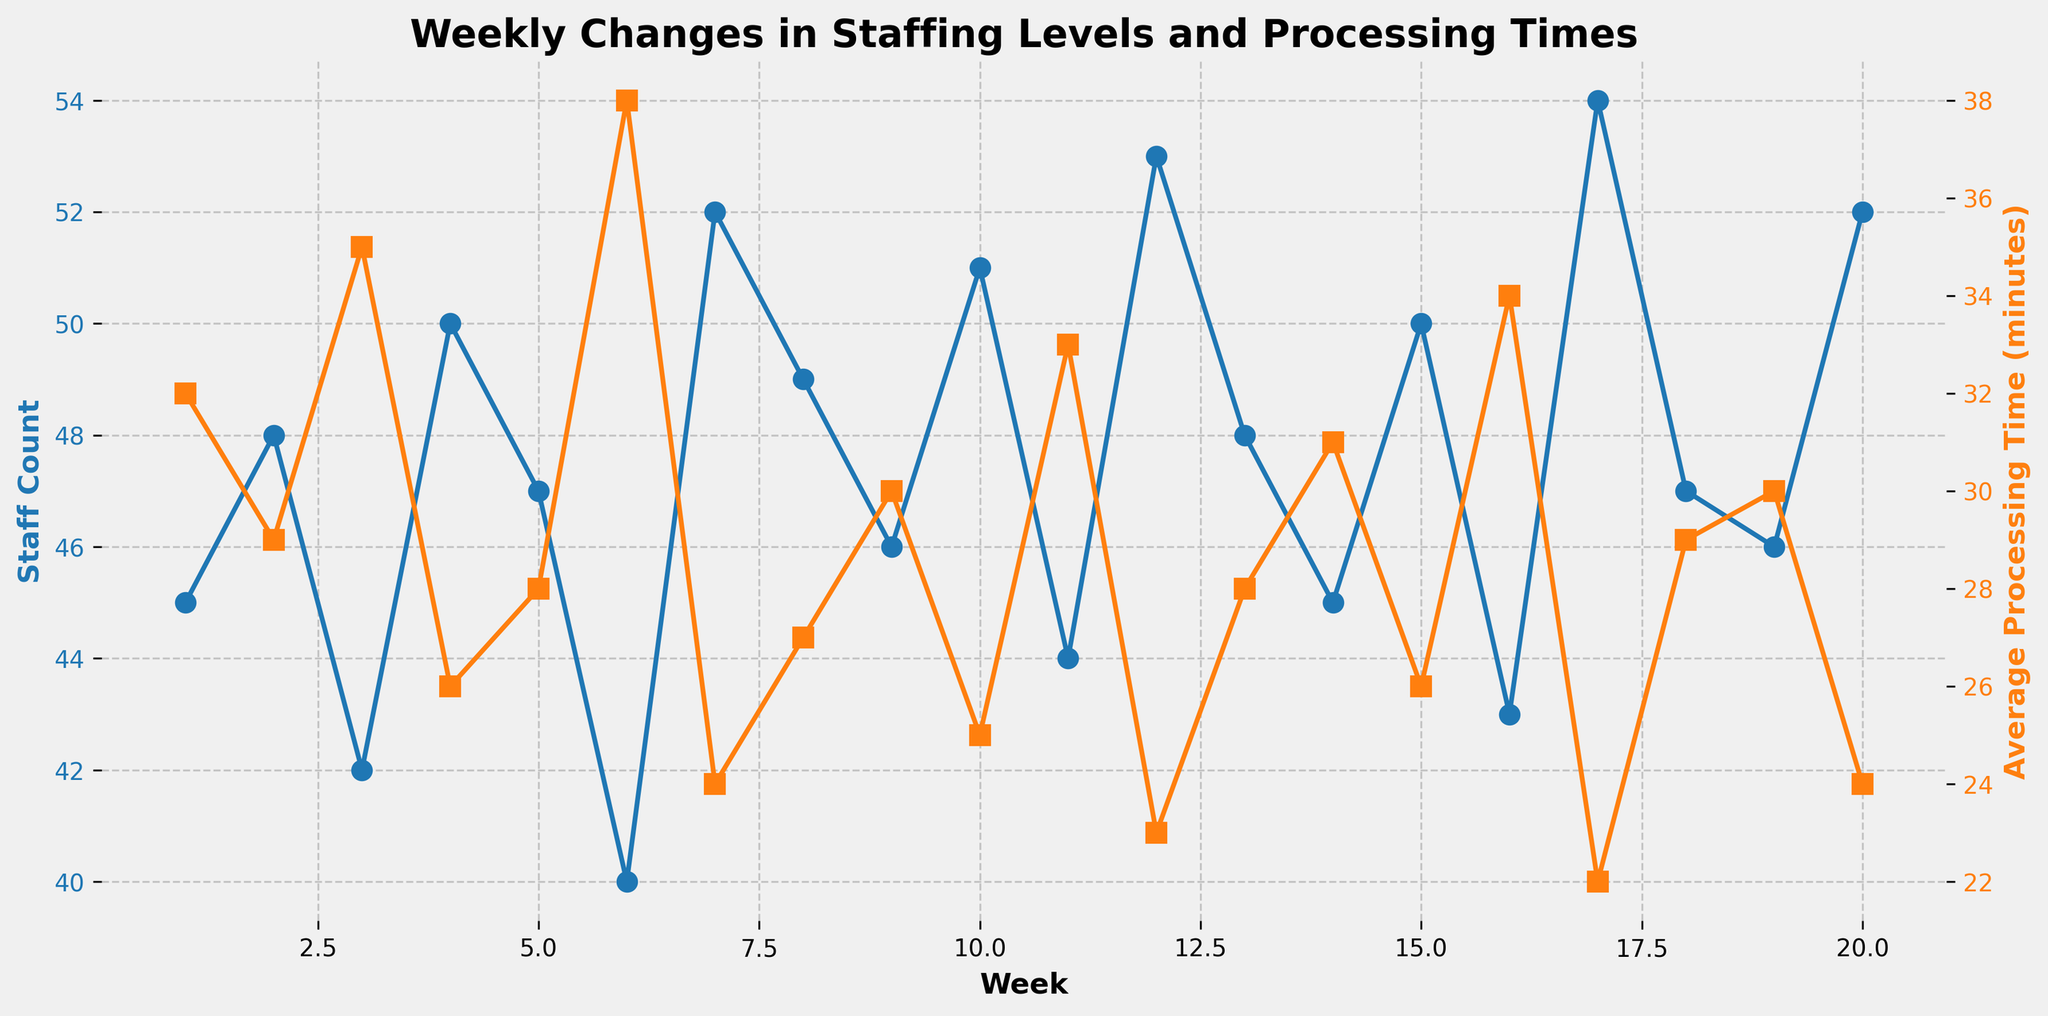What is the staff count in Week 10? Refer to the line representing staff count (blue). Find the data point at Week 10 which shows the staff count.
Answer: 51 What happens to the average processing time (in minutes) in Week 6? Refer to the line representing average processing time (orange). Locate the point at Week 6 to see the trend.
Answer: It increases to 38 minutes How does the average processing time in Week 4 compare to Week 6? Refer to the line representing average processing time (orange). In Week 4, the processing time is 26 minutes, while in Week 6, it is 38 minutes.
Answer: It is 12 minutes shorter Which week had the highest staff count, and what was it? Refer to the blue line for the highest point, which corresponds to the highest staff count. Look at Week 17 for the peak value.
Answer: Week 17 with 54 staff members How does the processing time change as the staff count increases from Week 1 to Week 4? Compare the processing times listed in Weeks 1 through 4 with their respective staff counts. Notice the trend: as staff count increases from 45 to 50, processing time decreases from 32 to 26 minutes.
Answer: It decreases During which weeks do we observe the lowest average processing time, and what is it? Refer to the orange line for the lowest point. Identify Week 17 where processing time drops to its lowest value.
Answer: Week 17 with 22 minutes If you look at weeks where the staff count is 50, what is the corresponding average processing time each time? Refer to the blue line to find weeks with staff count 50 (Weeks 4, 15). Check the corresponding orange points for the processing times.
Answer: 26 minutes each time Between Weeks 8 and 12, does the staff count increase, decrease, or stay stable? Track the blue line's trend between Week 8 and Week 12. Notice how it initially increases, then decreases, showing an upward then downward trend.
Answer: It varies; increases then decreases What is the difference between the highest and lowest average processing times recorded in the dataset? Refer to the orange line for the highest point (Week 6 at 38 minutes) and the lowest point (Week 17 at 22 minutes). Subtract the lowest from the highest.
Answer: 16 minutes How does the staff count in Week 2 compare to the staff count in Week 11? Refer to the blue line and note the staff counts for Week 2 (48) and Week 11 (44). Compare the figures.
Answer: It is 4 higher in Week 2 